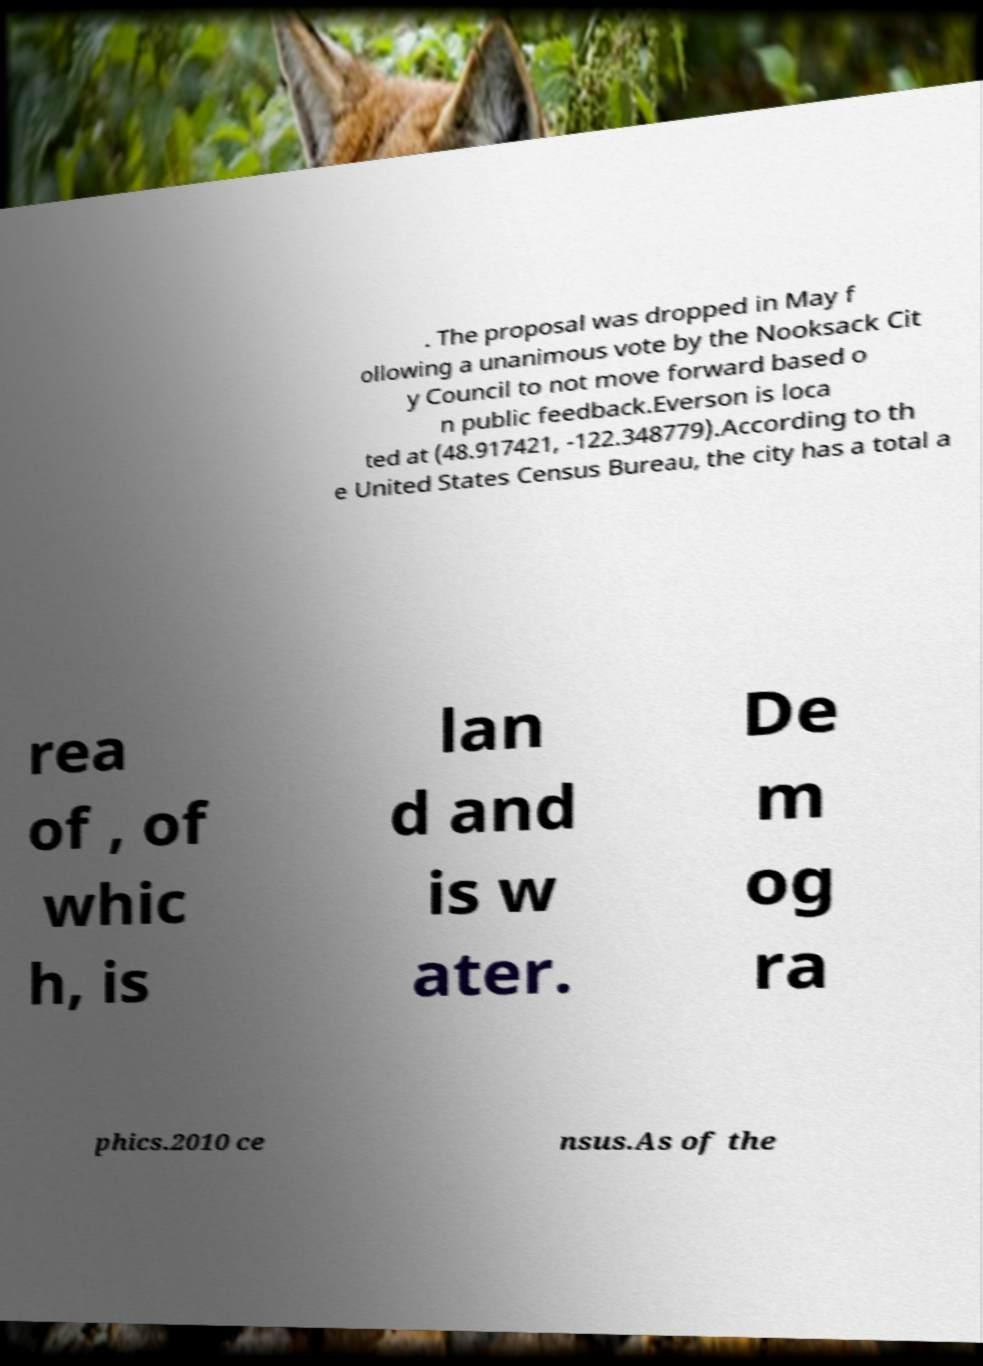I need the written content from this picture converted into text. Can you do that? . The proposal was dropped in May f ollowing a unanimous vote by the Nooksack Cit y Council to not move forward based o n public feedback.Everson is loca ted at (48.917421, -122.348779).According to th e United States Census Bureau, the city has a total a rea of , of whic h, is lan d and is w ater. De m og ra phics.2010 ce nsus.As of the 